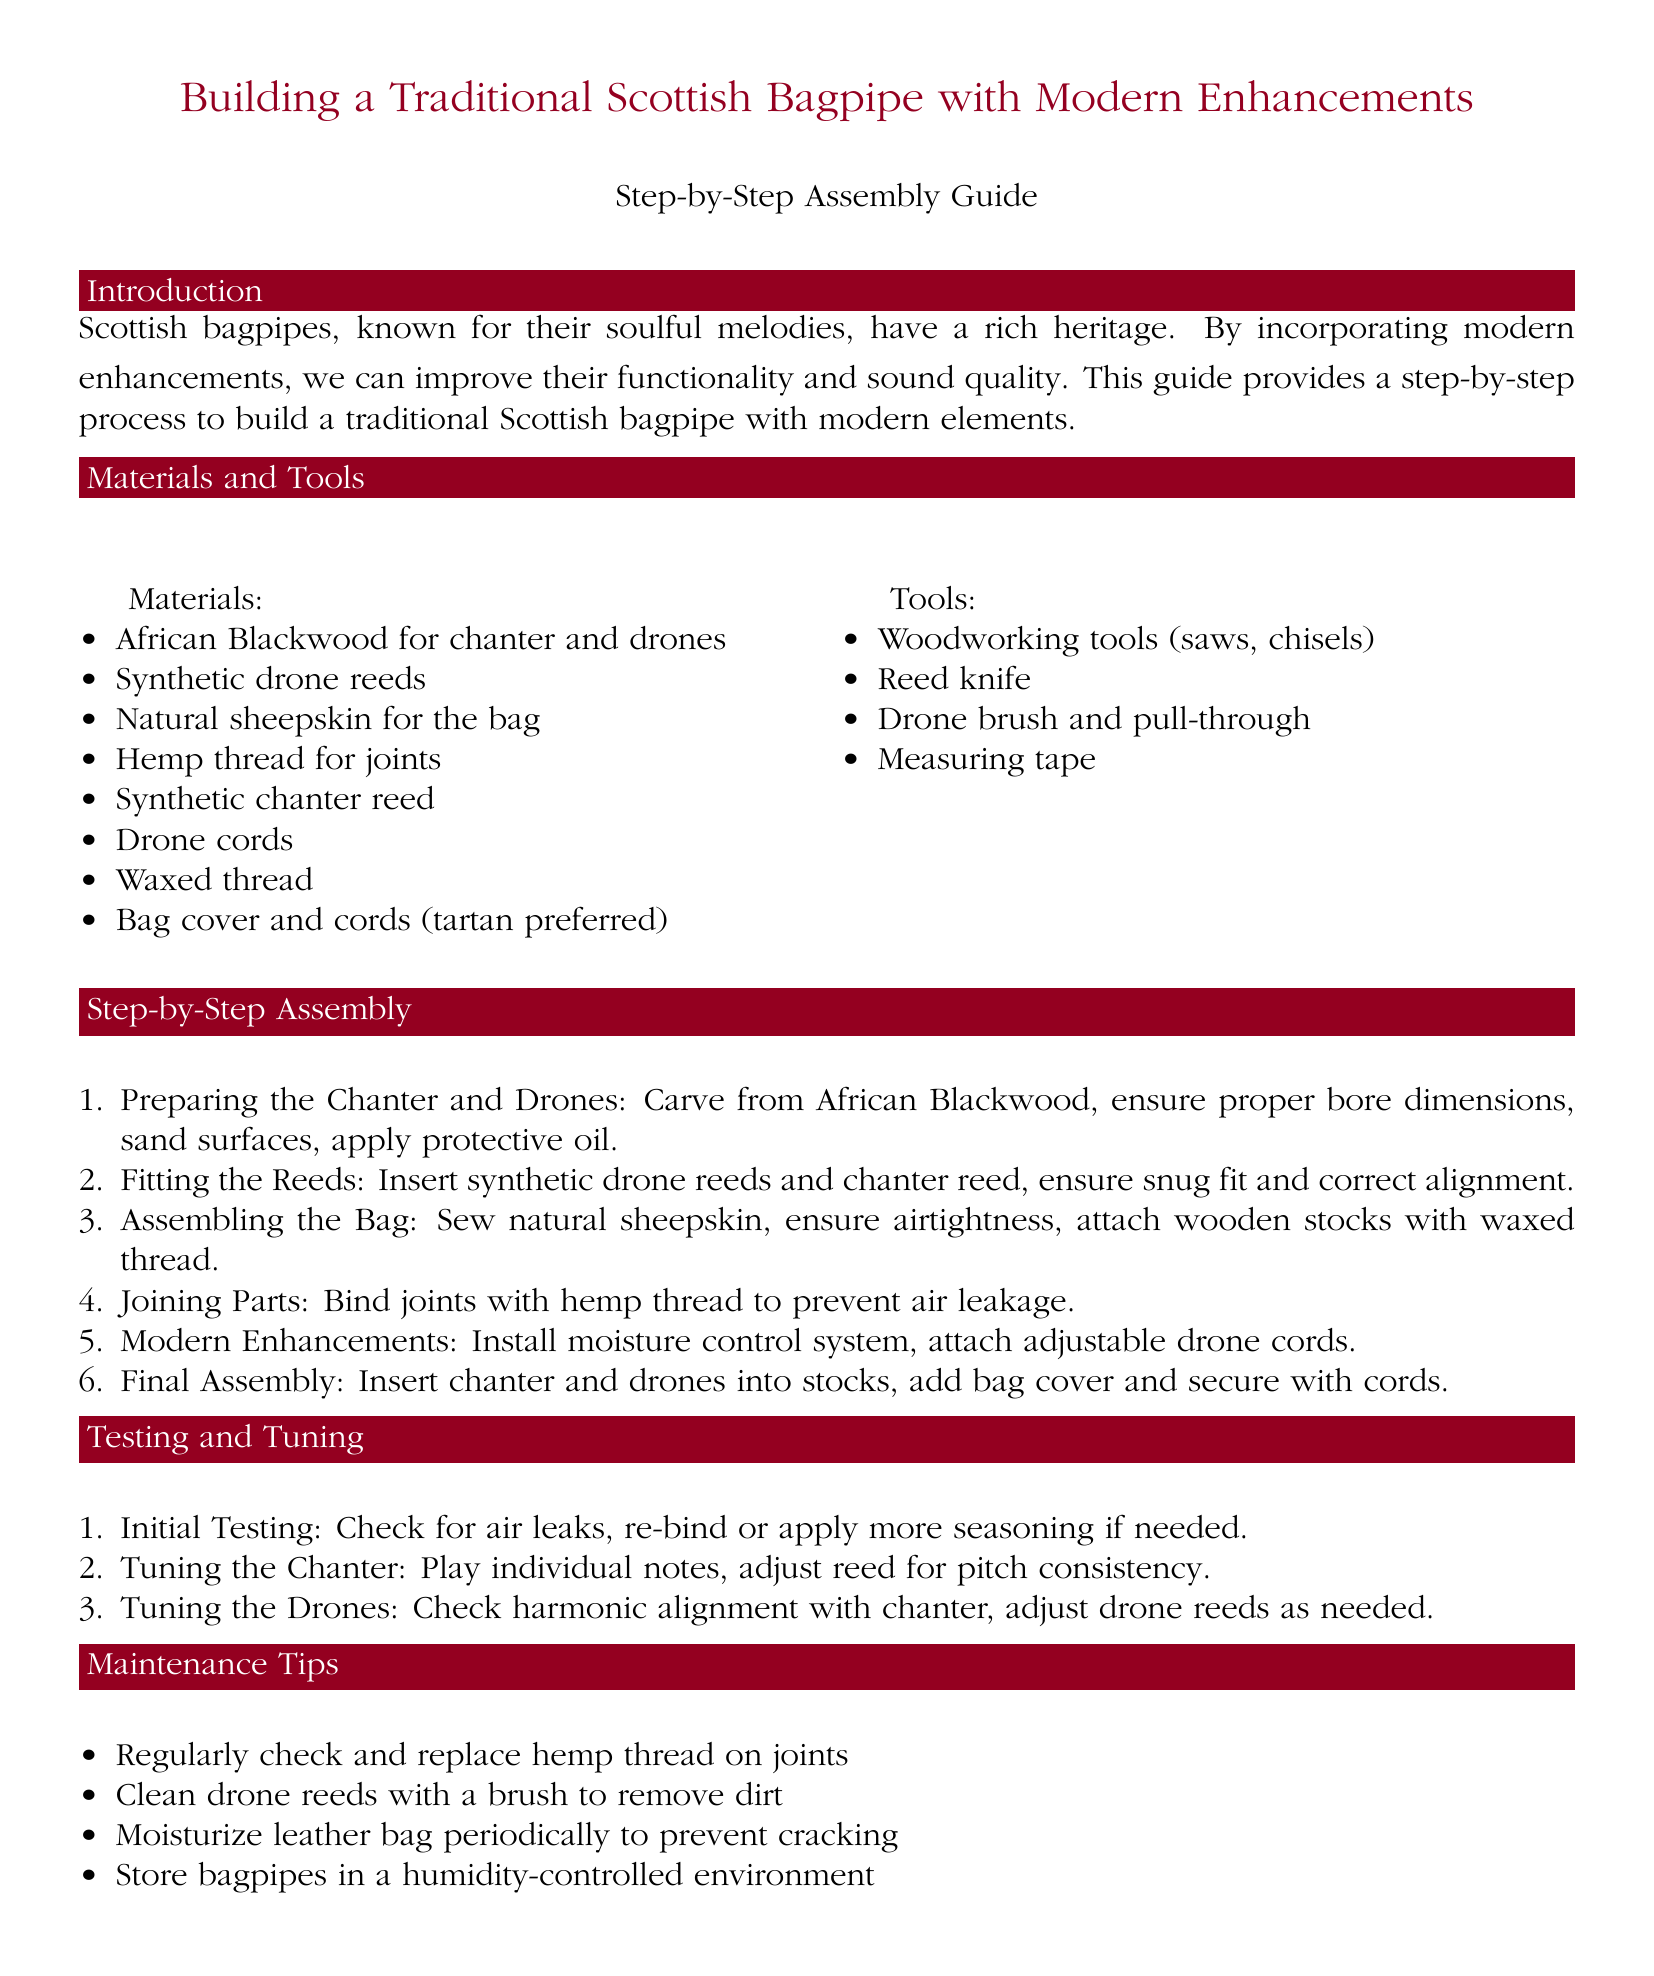What is the primary material for the chanter and drones? The document lists African Blackwood as the primary material for the chanter and drones.
Answer: African Blackwood What type of reeds are used for the drones? The assembly guide specifies synthetic drone reeds as the type used for the drones.
Answer: Synthetic drone reeds How many steps are outlined in the assembly process? The document enumerates six steps in the assembly process.
Answer: Six What should be used to bind joints to prevent air leakage? The guide recommends using hemp thread to bind joints.
Answer: Hemp thread What is one of the modern enhancements suggested for the bagpipes? The document mentions installing a moisture control system as a modern enhancement.
Answer: Moisture control system What is the first step in the assembly process? The first step involves preparing the chanter and drones by carving from African Blackwood.
Answer: Preparing the Chanter and Drones How often should the drone reeds be cleaned? While the document does not specify a frequency, it mentions to regularly clean the drone reeds.
Answer: Regularly What type of environment should bagpipes be stored in? The maintenance section advises storing bagpipes in a humidity-controlled environment.
Answer: Humidity-controlled environment During testing, what should be checked for initial testing? The initial testing requires checking for air leaks in the bagpipes.
Answer: Air leaks 